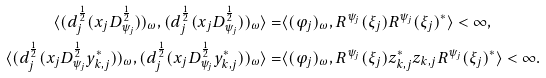<formula> <loc_0><loc_0><loc_500><loc_500>\langle ( d _ { j } ^ { \frac { 1 } { 2 } } ( x _ { j } D _ { \psi _ { j } } ^ { \frac { 1 } { 2 } } ) ) _ { \omega } , ( d _ { j } ^ { \frac { 1 } { 2 } } ( x _ { j } D _ { \psi _ { j } } ^ { \frac { 1 } { 2 } } ) ) _ { \omega } \rangle = & \langle ( \varphi _ { j } ) _ { \omega } , R ^ { \psi _ { j } } ( \xi _ { j } ) R ^ { \psi _ { j } } ( \xi _ { j } ) ^ { \ast } \rangle < \infty , \\ \langle ( d _ { j } ^ { \frac { 1 } { 2 } } ( x _ { j } D _ { \psi _ { j } } ^ { \frac { 1 } { 2 } } y _ { k , j } ^ { \ast } ) ) _ { \omega } , ( d _ { j } ^ { \frac { 1 } { 2 } } ( x _ { j } D _ { \psi _ { j } } ^ { \frac { 1 } { 2 } } y _ { k , j } ^ { \ast } ) ) _ { \omega } \rangle = & \langle ( \varphi _ { j } ) _ { \omega } , R ^ { \psi _ { j } } ( \xi _ { j } ) z _ { k , j } ^ { \ast } z _ { k , j } R ^ { \psi _ { j } } ( \xi _ { j } ) ^ { \ast } \rangle < \infty . \\</formula> 